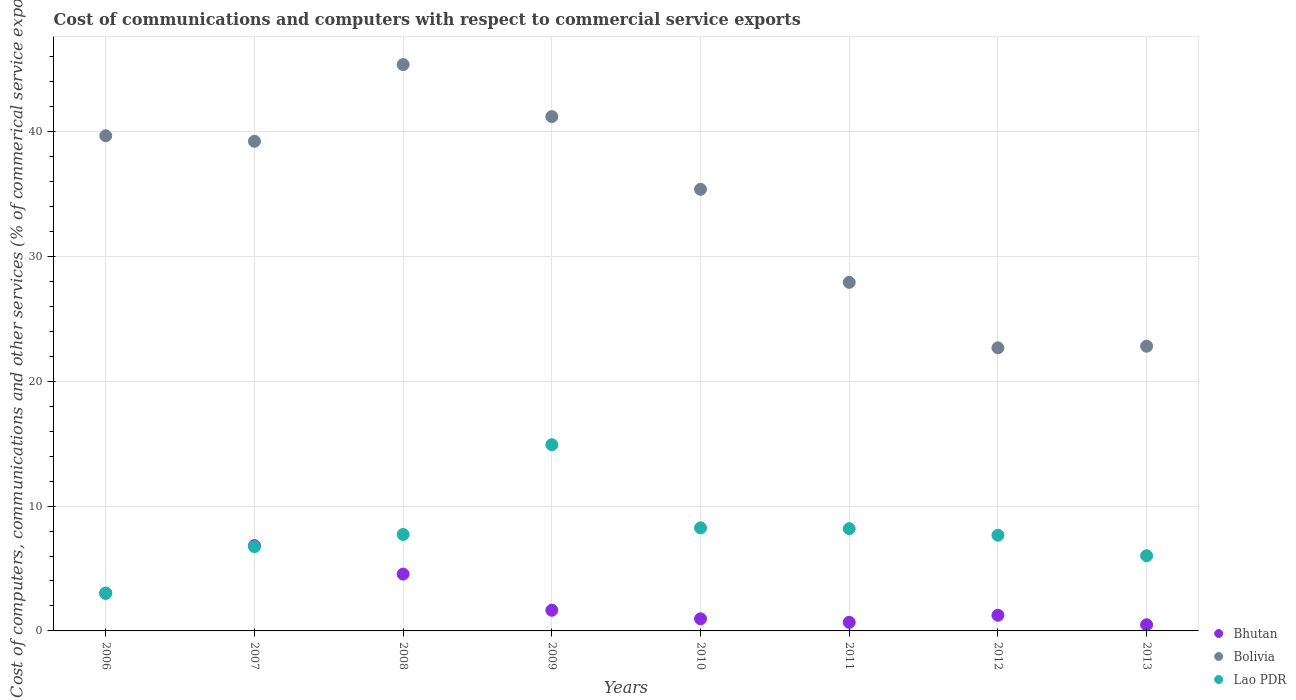How many different coloured dotlines are there?
Offer a terse response. 3. What is the cost of communications and computers in Bolivia in 2006?
Make the answer very short. 39.65. Across all years, what is the maximum cost of communications and computers in Bolivia?
Your answer should be very brief. 45.36. Across all years, what is the minimum cost of communications and computers in Lao PDR?
Offer a very short reply. 3.03. In which year was the cost of communications and computers in Lao PDR minimum?
Your answer should be compact. 2006. What is the total cost of communications and computers in Lao PDR in the graph?
Give a very brief answer. 62.54. What is the difference between the cost of communications and computers in Lao PDR in 2008 and that in 2009?
Provide a short and direct response. -7.19. What is the difference between the cost of communications and computers in Bhutan in 2010 and the cost of communications and computers in Lao PDR in 2012?
Offer a very short reply. -6.69. What is the average cost of communications and computers in Bhutan per year?
Provide a short and direct response. 2.43. In the year 2006, what is the difference between the cost of communications and computers in Lao PDR and cost of communications and computers in Bolivia?
Offer a terse response. -36.63. In how many years, is the cost of communications and computers in Lao PDR greater than 8 %?
Give a very brief answer. 3. What is the ratio of the cost of communications and computers in Bolivia in 2007 to that in 2013?
Ensure brevity in your answer.  1.72. What is the difference between the highest and the second highest cost of communications and computers in Bolivia?
Offer a very short reply. 4.16. What is the difference between the highest and the lowest cost of communications and computers in Lao PDR?
Keep it short and to the point. 11.88. Is the sum of the cost of communications and computers in Bolivia in 2006 and 2011 greater than the maximum cost of communications and computers in Lao PDR across all years?
Your answer should be very brief. Yes. Is it the case that in every year, the sum of the cost of communications and computers in Bhutan and cost of communications and computers in Lao PDR  is greater than the cost of communications and computers in Bolivia?
Provide a short and direct response. No. Does the cost of communications and computers in Lao PDR monotonically increase over the years?
Your response must be concise. No. Is the cost of communications and computers in Bhutan strictly greater than the cost of communications and computers in Bolivia over the years?
Ensure brevity in your answer.  No. Is the cost of communications and computers in Lao PDR strictly less than the cost of communications and computers in Bolivia over the years?
Provide a short and direct response. Yes. Are the values on the major ticks of Y-axis written in scientific E-notation?
Your answer should be compact. No. Where does the legend appear in the graph?
Your answer should be compact. Bottom right. What is the title of the graph?
Make the answer very short. Cost of communications and computers with respect to commercial service exports. What is the label or title of the Y-axis?
Make the answer very short. Cost of computers, communications and other services (% of commerical service exports). What is the Cost of computers, communications and other services (% of commerical service exports) in Bhutan in 2006?
Offer a very short reply. 3.02. What is the Cost of computers, communications and other services (% of commerical service exports) of Bolivia in 2006?
Provide a short and direct response. 39.65. What is the Cost of computers, communications and other services (% of commerical service exports) in Lao PDR in 2006?
Give a very brief answer. 3.03. What is the Cost of computers, communications and other services (% of commerical service exports) in Bhutan in 2007?
Give a very brief answer. 6.83. What is the Cost of computers, communications and other services (% of commerical service exports) in Bolivia in 2007?
Offer a terse response. 39.21. What is the Cost of computers, communications and other services (% of commerical service exports) of Lao PDR in 2007?
Your response must be concise. 6.74. What is the Cost of computers, communications and other services (% of commerical service exports) in Bhutan in 2008?
Your answer should be very brief. 4.55. What is the Cost of computers, communications and other services (% of commerical service exports) in Bolivia in 2008?
Keep it short and to the point. 45.36. What is the Cost of computers, communications and other services (% of commerical service exports) of Lao PDR in 2008?
Offer a very short reply. 7.72. What is the Cost of computers, communications and other services (% of commerical service exports) in Bhutan in 2009?
Offer a very short reply. 1.66. What is the Cost of computers, communications and other services (% of commerical service exports) of Bolivia in 2009?
Make the answer very short. 41.19. What is the Cost of computers, communications and other services (% of commerical service exports) in Lao PDR in 2009?
Give a very brief answer. 14.91. What is the Cost of computers, communications and other services (% of commerical service exports) of Bhutan in 2010?
Your response must be concise. 0.97. What is the Cost of computers, communications and other services (% of commerical service exports) in Bolivia in 2010?
Provide a succinct answer. 35.37. What is the Cost of computers, communications and other services (% of commerical service exports) of Lao PDR in 2010?
Offer a very short reply. 8.25. What is the Cost of computers, communications and other services (% of commerical service exports) in Bhutan in 2011?
Keep it short and to the point. 0.69. What is the Cost of computers, communications and other services (% of commerical service exports) of Bolivia in 2011?
Offer a terse response. 27.92. What is the Cost of computers, communications and other services (% of commerical service exports) in Lao PDR in 2011?
Make the answer very short. 8.19. What is the Cost of computers, communications and other services (% of commerical service exports) of Bhutan in 2012?
Give a very brief answer. 1.25. What is the Cost of computers, communications and other services (% of commerical service exports) in Bolivia in 2012?
Offer a very short reply. 22.67. What is the Cost of computers, communications and other services (% of commerical service exports) of Lao PDR in 2012?
Your answer should be compact. 7.66. What is the Cost of computers, communications and other services (% of commerical service exports) of Bhutan in 2013?
Keep it short and to the point. 0.49. What is the Cost of computers, communications and other services (% of commerical service exports) in Bolivia in 2013?
Give a very brief answer. 22.8. What is the Cost of computers, communications and other services (% of commerical service exports) in Lao PDR in 2013?
Ensure brevity in your answer.  6.02. Across all years, what is the maximum Cost of computers, communications and other services (% of commerical service exports) of Bhutan?
Your answer should be compact. 6.83. Across all years, what is the maximum Cost of computers, communications and other services (% of commerical service exports) in Bolivia?
Offer a very short reply. 45.36. Across all years, what is the maximum Cost of computers, communications and other services (% of commerical service exports) of Lao PDR?
Offer a terse response. 14.91. Across all years, what is the minimum Cost of computers, communications and other services (% of commerical service exports) in Bhutan?
Provide a short and direct response. 0.49. Across all years, what is the minimum Cost of computers, communications and other services (% of commerical service exports) of Bolivia?
Provide a succinct answer. 22.67. Across all years, what is the minimum Cost of computers, communications and other services (% of commerical service exports) of Lao PDR?
Offer a very short reply. 3.03. What is the total Cost of computers, communications and other services (% of commerical service exports) in Bhutan in the graph?
Your response must be concise. 19.46. What is the total Cost of computers, communications and other services (% of commerical service exports) in Bolivia in the graph?
Make the answer very short. 274.17. What is the total Cost of computers, communications and other services (% of commerical service exports) of Lao PDR in the graph?
Your answer should be compact. 62.54. What is the difference between the Cost of computers, communications and other services (% of commerical service exports) of Bhutan in 2006 and that in 2007?
Your answer should be compact. -3.81. What is the difference between the Cost of computers, communications and other services (% of commerical service exports) of Bolivia in 2006 and that in 2007?
Offer a terse response. 0.44. What is the difference between the Cost of computers, communications and other services (% of commerical service exports) in Lao PDR in 2006 and that in 2007?
Your answer should be very brief. -3.71. What is the difference between the Cost of computers, communications and other services (% of commerical service exports) in Bhutan in 2006 and that in 2008?
Offer a very short reply. -1.53. What is the difference between the Cost of computers, communications and other services (% of commerical service exports) in Bolivia in 2006 and that in 2008?
Offer a terse response. -5.7. What is the difference between the Cost of computers, communications and other services (% of commerical service exports) of Lao PDR in 2006 and that in 2008?
Your response must be concise. -4.69. What is the difference between the Cost of computers, communications and other services (% of commerical service exports) in Bhutan in 2006 and that in 2009?
Your answer should be compact. 1.36. What is the difference between the Cost of computers, communications and other services (% of commerical service exports) in Bolivia in 2006 and that in 2009?
Offer a terse response. -1.54. What is the difference between the Cost of computers, communications and other services (% of commerical service exports) in Lao PDR in 2006 and that in 2009?
Your answer should be very brief. -11.88. What is the difference between the Cost of computers, communications and other services (% of commerical service exports) in Bhutan in 2006 and that in 2010?
Make the answer very short. 2.05. What is the difference between the Cost of computers, communications and other services (% of commerical service exports) of Bolivia in 2006 and that in 2010?
Offer a terse response. 4.29. What is the difference between the Cost of computers, communications and other services (% of commerical service exports) of Lao PDR in 2006 and that in 2010?
Your answer should be compact. -5.22. What is the difference between the Cost of computers, communications and other services (% of commerical service exports) of Bhutan in 2006 and that in 2011?
Ensure brevity in your answer.  2.33. What is the difference between the Cost of computers, communications and other services (% of commerical service exports) in Bolivia in 2006 and that in 2011?
Provide a succinct answer. 11.74. What is the difference between the Cost of computers, communications and other services (% of commerical service exports) of Lao PDR in 2006 and that in 2011?
Your answer should be very brief. -5.16. What is the difference between the Cost of computers, communications and other services (% of commerical service exports) in Bhutan in 2006 and that in 2012?
Offer a terse response. 1.76. What is the difference between the Cost of computers, communications and other services (% of commerical service exports) in Bolivia in 2006 and that in 2012?
Make the answer very short. 16.99. What is the difference between the Cost of computers, communications and other services (% of commerical service exports) of Lao PDR in 2006 and that in 2012?
Provide a short and direct response. -4.63. What is the difference between the Cost of computers, communications and other services (% of commerical service exports) of Bhutan in 2006 and that in 2013?
Your answer should be compact. 2.52. What is the difference between the Cost of computers, communications and other services (% of commerical service exports) of Bolivia in 2006 and that in 2013?
Your answer should be compact. 16.85. What is the difference between the Cost of computers, communications and other services (% of commerical service exports) of Lao PDR in 2006 and that in 2013?
Your answer should be compact. -2.99. What is the difference between the Cost of computers, communications and other services (% of commerical service exports) in Bhutan in 2007 and that in 2008?
Give a very brief answer. 2.28. What is the difference between the Cost of computers, communications and other services (% of commerical service exports) of Bolivia in 2007 and that in 2008?
Provide a succinct answer. -6.14. What is the difference between the Cost of computers, communications and other services (% of commerical service exports) of Lao PDR in 2007 and that in 2008?
Keep it short and to the point. -0.98. What is the difference between the Cost of computers, communications and other services (% of commerical service exports) of Bhutan in 2007 and that in 2009?
Give a very brief answer. 5.18. What is the difference between the Cost of computers, communications and other services (% of commerical service exports) of Bolivia in 2007 and that in 2009?
Provide a short and direct response. -1.98. What is the difference between the Cost of computers, communications and other services (% of commerical service exports) of Lao PDR in 2007 and that in 2009?
Provide a succinct answer. -8.17. What is the difference between the Cost of computers, communications and other services (% of commerical service exports) of Bhutan in 2007 and that in 2010?
Offer a very short reply. 5.86. What is the difference between the Cost of computers, communications and other services (% of commerical service exports) of Bolivia in 2007 and that in 2010?
Keep it short and to the point. 3.85. What is the difference between the Cost of computers, communications and other services (% of commerical service exports) of Lao PDR in 2007 and that in 2010?
Your response must be concise. -1.51. What is the difference between the Cost of computers, communications and other services (% of commerical service exports) in Bhutan in 2007 and that in 2011?
Your answer should be compact. 6.14. What is the difference between the Cost of computers, communications and other services (% of commerical service exports) of Bolivia in 2007 and that in 2011?
Your response must be concise. 11.3. What is the difference between the Cost of computers, communications and other services (% of commerical service exports) in Lao PDR in 2007 and that in 2011?
Provide a short and direct response. -1.45. What is the difference between the Cost of computers, communications and other services (% of commerical service exports) of Bhutan in 2007 and that in 2012?
Provide a short and direct response. 5.58. What is the difference between the Cost of computers, communications and other services (% of commerical service exports) in Bolivia in 2007 and that in 2012?
Offer a very short reply. 16.54. What is the difference between the Cost of computers, communications and other services (% of commerical service exports) of Lao PDR in 2007 and that in 2012?
Offer a very short reply. -0.92. What is the difference between the Cost of computers, communications and other services (% of commerical service exports) in Bhutan in 2007 and that in 2013?
Your answer should be very brief. 6.34. What is the difference between the Cost of computers, communications and other services (% of commerical service exports) of Bolivia in 2007 and that in 2013?
Keep it short and to the point. 16.41. What is the difference between the Cost of computers, communications and other services (% of commerical service exports) in Lao PDR in 2007 and that in 2013?
Provide a short and direct response. 0.72. What is the difference between the Cost of computers, communications and other services (% of commerical service exports) of Bhutan in 2008 and that in 2009?
Provide a short and direct response. 2.89. What is the difference between the Cost of computers, communications and other services (% of commerical service exports) of Bolivia in 2008 and that in 2009?
Provide a succinct answer. 4.16. What is the difference between the Cost of computers, communications and other services (% of commerical service exports) of Lao PDR in 2008 and that in 2009?
Your answer should be compact. -7.19. What is the difference between the Cost of computers, communications and other services (% of commerical service exports) of Bhutan in 2008 and that in 2010?
Your answer should be very brief. 3.58. What is the difference between the Cost of computers, communications and other services (% of commerical service exports) in Bolivia in 2008 and that in 2010?
Ensure brevity in your answer.  9.99. What is the difference between the Cost of computers, communications and other services (% of commerical service exports) of Lao PDR in 2008 and that in 2010?
Offer a terse response. -0.53. What is the difference between the Cost of computers, communications and other services (% of commerical service exports) of Bhutan in 2008 and that in 2011?
Keep it short and to the point. 3.86. What is the difference between the Cost of computers, communications and other services (% of commerical service exports) of Bolivia in 2008 and that in 2011?
Offer a very short reply. 17.44. What is the difference between the Cost of computers, communications and other services (% of commerical service exports) of Lao PDR in 2008 and that in 2011?
Ensure brevity in your answer.  -0.46. What is the difference between the Cost of computers, communications and other services (% of commerical service exports) of Bhutan in 2008 and that in 2012?
Provide a succinct answer. 3.3. What is the difference between the Cost of computers, communications and other services (% of commerical service exports) of Bolivia in 2008 and that in 2012?
Your response must be concise. 22.69. What is the difference between the Cost of computers, communications and other services (% of commerical service exports) of Lao PDR in 2008 and that in 2012?
Keep it short and to the point. 0.06. What is the difference between the Cost of computers, communications and other services (% of commerical service exports) in Bhutan in 2008 and that in 2013?
Your answer should be very brief. 4.06. What is the difference between the Cost of computers, communications and other services (% of commerical service exports) of Bolivia in 2008 and that in 2013?
Offer a very short reply. 22.55. What is the difference between the Cost of computers, communications and other services (% of commerical service exports) of Lao PDR in 2008 and that in 2013?
Ensure brevity in your answer.  1.7. What is the difference between the Cost of computers, communications and other services (% of commerical service exports) in Bhutan in 2009 and that in 2010?
Your answer should be very brief. 0.69. What is the difference between the Cost of computers, communications and other services (% of commerical service exports) of Bolivia in 2009 and that in 2010?
Make the answer very short. 5.82. What is the difference between the Cost of computers, communications and other services (% of commerical service exports) of Lao PDR in 2009 and that in 2010?
Make the answer very short. 6.66. What is the difference between the Cost of computers, communications and other services (% of commerical service exports) in Bhutan in 2009 and that in 2011?
Provide a short and direct response. 0.97. What is the difference between the Cost of computers, communications and other services (% of commerical service exports) in Bolivia in 2009 and that in 2011?
Your response must be concise. 13.28. What is the difference between the Cost of computers, communications and other services (% of commerical service exports) in Lao PDR in 2009 and that in 2011?
Offer a very short reply. 6.72. What is the difference between the Cost of computers, communications and other services (% of commerical service exports) in Bhutan in 2009 and that in 2012?
Ensure brevity in your answer.  0.4. What is the difference between the Cost of computers, communications and other services (% of commerical service exports) of Bolivia in 2009 and that in 2012?
Your answer should be very brief. 18.52. What is the difference between the Cost of computers, communications and other services (% of commerical service exports) in Lao PDR in 2009 and that in 2012?
Your answer should be very brief. 7.25. What is the difference between the Cost of computers, communications and other services (% of commerical service exports) in Bhutan in 2009 and that in 2013?
Your response must be concise. 1.16. What is the difference between the Cost of computers, communications and other services (% of commerical service exports) of Bolivia in 2009 and that in 2013?
Keep it short and to the point. 18.39. What is the difference between the Cost of computers, communications and other services (% of commerical service exports) in Lao PDR in 2009 and that in 2013?
Make the answer very short. 8.89. What is the difference between the Cost of computers, communications and other services (% of commerical service exports) of Bhutan in 2010 and that in 2011?
Your answer should be compact. 0.28. What is the difference between the Cost of computers, communications and other services (% of commerical service exports) of Bolivia in 2010 and that in 2011?
Your answer should be very brief. 7.45. What is the difference between the Cost of computers, communications and other services (% of commerical service exports) of Lao PDR in 2010 and that in 2011?
Give a very brief answer. 0.06. What is the difference between the Cost of computers, communications and other services (% of commerical service exports) of Bhutan in 2010 and that in 2012?
Provide a succinct answer. -0.28. What is the difference between the Cost of computers, communications and other services (% of commerical service exports) of Bolivia in 2010 and that in 2012?
Provide a short and direct response. 12.7. What is the difference between the Cost of computers, communications and other services (% of commerical service exports) in Lao PDR in 2010 and that in 2012?
Your answer should be very brief. 0.59. What is the difference between the Cost of computers, communications and other services (% of commerical service exports) of Bhutan in 2010 and that in 2013?
Offer a terse response. 0.47. What is the difference between the Cost of computers, communications and other services (% of commerical service exports) of Bolivia in 2010 and that in 2013?
Offer a terse response. 12.57. What is the difference between the Cost of computers, communications and other services (% of commerical service exports) in Lao PDR in 2010 and that in 2013?
Give a very brief answer. 2.23. What is the difference between the Cost of computers, communications and other services (% of commerical service exports) in Bhutan in 2011 and that in 2012?
Ensure brevity in your answer.  -0.56. What is the difference between the Cost of computers, communications and other services (% of commerical service exports) in Bolivia in 2011 and that in 2012?
Offer a terse response. 5.25. What is the difference between the Cost of computers, communications and other services (% of commerical service exports) of Lao PDR in 2011 and that in 2012?
Your response must be concise. 0.53. What is the difference between the Cost of computers, communications and other services (% of commerical service exports) of Bhutan in 2011 and that in 2013?
Your answer should be compact. 0.2. What is the difference between the Cost of computers, communications and other services (% of commerical service exports) of Bolivia in 2011 and that in 2013?
Offer a very short reply. 5.11. What is the difference between the Cost of computers, communications and other services (% of commerical service exports) of Lao PDR in 2011 and that in 2013?
Offer a very short reply. 2.17. What is the difference between the Cost of computers, communications and other services (% of commerical service exports) of Bhutan in 2012 and that in 2013?
Give a very brief answer. 0.76. What is the difference between the Cost of computers, communications and other services (% of commerical service exports) in Bolivia in 2012 and that in 2013?
Offer a very short reply. -0.13. What is the difference between the Cost of computers, communications and other services (% of commerical service exports) in Lao PDR in 2012 and that in 2013?
Make the answer very short. 1.64. What is the difference between the Cost of computers, communications and other services (% of commerical service exports) of Bhutan in 2006 and the Cost of computers, communications and other services (% of commerical service exports) of Bolivia in 2007?
Offer a very short reply. -36.2. What is the difference between the Cost of computers, communications and other services (% of commerical service exports) of Bhutan in 2006 and the Cost of computers, communications and other services (% of commerical service exports) of Lao PDR in 2007?
Your answer should be compact. -3.73. What is the difference between the Cost of computers, communications and other services (% of commerical service exports) of Bolivia in 2006 and the Cost of computers, communications and other services (% of commerical service exports) of Lao PDR in 2007?
Give a very brief answer. 32.91. What is the difference between the Cost of computers, communications and other services (% of commerical service exports) in Bhutan in 2006 and the Cost of computers, communications and other services (% of commerical service exports) in Bolivia in 2008?
Give a very brief answer. -42.34. What is the difference between the Cost of computers, communications and other services (% of commerical service exports) of Bhutan in 2006 and the Cost of computers, communications and other services (% of commerical service exports) of Lao PDR in 2008?
Make the answer very short. -4.71. What is the difference between the Cost of computers, communications and other services (% of commerical service exports) of Bolivia in 2006 and the Cost of computers, communications and other services (% of commerical service exports) of Lao PDR in 2008?
Your response must be concise. 31.93. What is the difference between the Cost of computers, communications and other services (% of commerical service exports) in Bhutan in 2006 and the Cost of computers, communications and other services (% of commerical service exports) in Bolivia in 2009?
Give a very brief answer. -38.17. What is the difference between the Cost of computers, communications and other services (% of commerical service exports) of Bhutan in 2006 and the Cost of computers, communications and other services (% of commerical service exports) of Lao PDR in 2009?
Offer a terse response. -11.9. What is the difference between the Cost of computers, communications and other services (% of commerical service exports) of Bolivia in 2006 and the Cost of computers, communications and other services (% of commerical service exports) of Lao PDR in 2009?
Make the answer very short. 24.74. What is the difference between the Cost of computers, communications and other services (% of commerical service exports) in Bhutan in 2006 and the Cost of computers, communications and other services (% of commerical service exports) in Bolivia in 2010?
Offer a terse response. -32.35. What is the difference between the Cost of computers, communications and other services (% of commerical service exports) of Bhutan in 2006 and the Cost of computers, communications and other services (% of commerical service exports) of Lao PDR in 2010?
Offer a very short reply. -5.24. What is the difference between the Cost of computers, communications and other services (% of commerical service exports) in Bolivia in 2006 and the Cost of computers, communications and other services (% of commerical service exports) in Lao PDR in 2010?
Provide a succinct answer. 31.4. What is the difference between the Cost of computers, communications and other services (% of commerical service exports) of Bhutan in 2006 and the Cost of computers, communications and other services (% of commerical service exports) of Bolivia in 2011?
Your answer should be compact. -24.9. What is the difference between the Cost of computers, communications and other services (% of commerical service exports) in Bhutan in 2006 and the Cost of computers, communications and other services (% of commerical service exports) in Lao PDR in 2011?
Make the answer very short. -5.17. What is the difference between the Cost of computers, communications and other services (% of commerical service exports) of Bolivia in 2006 and the Cost of computers, communications and other services (% of commerical service exports) of Lao PDR in 2011?
Offer a terse response. 31.47. What is the difference between the Cost of computers, communications and other services (% of commerical service exports) in Bhutan in 2006 and the Cost of computers, communications and other services (% of commerical service exports) in Bolivia in 2012?
Keep it short and to the point. -19.65. What is the difference between the Cost of computers, communications and other services (% of commerical service exports) in Bhutan in 2006 and the Cost of computers, communications and other services (% of commerical service exports) in Lao PDR in 2012?
Provide a short and direct response. -4.65. What is the difference between the Cost of computers, communications and other services (% of commerical service exports) of Bolivia in 2006 and the Cost of computers, communications and other services (% of commerical service exports) of Lao PDR in 2012?
Your answer should be very brief. 31.99. What is the difference between the Cost of computers, communications and other services (% of commerical service exports) in Bhutan in 2006 and the Cost of computers, communications and other services (% of commerical service exports) in Bolivia in 2013?
Keep it short and to the point. -19.78. What is the difference between the Cost of computers, communications and other services (% of commerical service exports) of Bhutan in 2006 and the Cost of computers, communications and other services (% of commerical service exports) of Lao PDR in 2013?
Offer a terse response. -3.01. What is the difference between the Cost of computers, communications and other services (% of commerical service exports) in Bolivia in 2006 and the Cost of computers, communications and other services (% of commerical service exports) in Lao PDR in 2013?
Ensure brevity in your answer.  33.63. What is the difference between the Cost of computers, communications and other services (% of commerical service exports) of Bhutan in 2007 and the Cost of computers, communications and other services (% of commerical service exports) of Bolivia in 2008?
Your answer should be compact. -38.52. What is the difference between the Cost of computers, communications and other services (% of commerical service exports) in Bhutan in 2007 and the Cost of computers, communications and other services (% of commerical service exports) in Lao PDR in 2008?
Offer a terse response. -0.89. What is the difference between the Cost of computers, communications and other services (% of commerical service exports) in Bolivia in 2007 and the Cost of computers, communications and other services (% of commerical service exports) in Lao PDR in 2008?
Keep it short and to the point. 31.49. What is the difference between the Cost of computers, communications and other services (% of commerical service exports) of Bhutan in 2007 and the Cost of computers, communications and other services (% of commerical service exports) of Bolivia in 2009?
Offer a terse response. -34.36. What is the difference between the Cost of computers, communications and other services (% of commerical service exports) of Bhutan in 2007 and the Cost of computers, communications and other services (% of commerical service exports) of Lao PDR in 2009?
Your answer should be very brief. -8.08. What is the difference between the Cost of computers, communications and other services (% of commerical service exports) in Bolivia in 2007 and the Cost of computers, communications and other services (% of commerical service exports) in Lao PDR in 2009?
Provide a short and direct response. 24.3. What is the difference between the Cost of computers, communications and other services (% of commerical service exports) in Bhutan in 2007 and the Cost of computers, communications and other services (% of commerical service exports) in Bolivia in 2010?
Your answer should be very brief. -28.53. What is the difference between the Cost of computers, communications and other services (% of commerical service exports) of Bhutan in 2007 and the Cost of computers, communications and other services (% of commerical service exports) of Lao PDR in 2010?
Provide a short and direct response. -1.42. What is the difference between the Cost of computers, communications and other services (% of commerical service exports) of Bolivia in 2007 and the Cost of computers, communications and other services (% of commerical service exports) of Lao PDR in 2010?
Your answer should be compact. 30.96. What is the difference between the Cost of computers, communications and other services (% of commerical service exports) of Bhutan in 2007 and the Cost of computers, communications and other services (% of commerical service exports) of Bolivia in 2011?
Keep it short and to the point. -21.08. What is the difference between the Cost of computers, communications and other services (% of commerical service exports) of Bhutan in 2007 and the Cost of computers, communications and other services (% of commerical service exports) of Lao PDR in 2011?
Offer a terse response. -1.36. What is the difference between the Cost of computers, communications and other services (% of commerical service exports) of Bolivia in 2007 and the Cost of computers, communications and other services (% of commerical service exports) of Lao PDR in 2011?
Make the answer very short. 31.02. What is the difference between the Cost of computers, communications and other services (% of commerical service exports) of Bhutan in 2007 and the Cost of computers, communications and other services (% of commerical service exports) of Bolivia in 2012?
Provide a succinct answer. -15.84. What is the difference between the Cost of computers, communications and other services (% of commerical service exports) of Bhutan in 2007 and the Cost of computers, communications and other services (% of commerical service exports) of Lao PDR in 2012?
Give a very brief answer. -0.83. What is the difference between the Cost of computers, communications and other services (% of commerical service exports) of Bolivia in 2007 and the Cost of computers, communications and other services (% of commerical service exports) of Lao PDR in 2012?
Your answer should be very brief. 31.55. What is the difference between the Cost of computers, communications and other services (% of commerical service exports) in Bhutan in 2007 and the Cost of computers, communications and other services (% of commerical service exports) in Bolivia in 2013?
Offer a terse response. -15.97. What is the difference between the Cost of computers, communications and other services (% of commerical service exports) of Bhutan in 2007 and the Cost of computers, communications and other services (% of commerical service exports) of Lao PDR in 2013?
Your answer should be very brief. 0.81. What is the difference between the Cost of computers, communications and other services (% of commerical service exports) of Bolivia in 2007 and the Cost of computers, communications and other services (% of commerical service exports) of Lao PDR in 2013?
Give a very brief answer. 33.19. What is the difference between the Cost of computers, communications and other services (% of commerical service exports) in Bhutan in 2008 and the Cost of computers, communications and other services (% of commerical service exports) in Bolivia in 2009?
Provide a succinct answer. -36.64. What is the difference between the Cost of computers, communications and other services (% of commerical service exports) in Bhutan in 2008 and the Cost of computers, communications and other services (% of commerical service exports) in Lao PDR in 2009?
Give a very brief answer. -10.36. What is the difference between the Cost of computers, communications and other services (% of commerical service exports) in Bolivia in 2008 and the Cost of computers, communications and other services (% of commerical service exports) in Lao PDR in 2009?
Offer a terse response. 30.44. What is the difference between the Cost of computers, communications and other services (% of commerical service exports) in Bhutan in 2008 and the Cost of computers, communications and other services (% of commerical service exports) in Bolivia in 2010?
Your answer should be compact. -30.82. What is the difference between the Cost of computers, communications and other services (% of commerical service exports) in Bhutan in 2008 and the Cost of computers, communications and other services (% of commerical service exports) in Lao PDR in 2010?
Ensure brevity in your answer.  -3.7. What is the difference between the Cost of computers, communications and other services (% of commerical service exports) of Bolivia in 2008 and the Cost of computers, communications and other services (% of commerical service exports) of Lao PDR in 2010?
Provide a short and direct response. 37.1. What is the difference between the Cost of computers, communications and other services (% of commerical service exports) of Bhutan in 2008 and the Cost of computers, communications and other services (% of commerical service exports) of Bolivia in 2011?
Offer a very short reply. -23.36. What is the difference between the Cost of computers, communications and other services (% of commerical service exports) in Bhutan in 2008 and the Cost of computers, communications and other services (% of commerical service exports) in Lao PDR in 2011?
Make the answer very short. -3.64. What is the difference between the Cost of computers, communications and other services (% of commerical service exports) of Bolivia in 2008 and the Cost of computers, communications and other services (% of commerical service exports) of Lao PDR in 2011?
Give a very brief answer. 37.17. What is the difference between the Cost of computers, communications and other services (% of commerical service exports) in Bhutan in 2008 and the Cost of computers, communications and other services (% of commerical service exports) in Bolivia in 2012?
Your answer should be very brief. -18.12. What is the difference between the Cost of computers, communications and other services (% of commerical service exports) in Bhutan in 2008 and the Cost of computers, communications and other services (% of commerical service exports) in Lao PDR in 2012?
Provide a short and direct response. -3.11. What is the difference between the Cost of computers, communications and other services (% of commerical service exports) in Bolivia in 2008 and the Cost of computers, communications and other services (% of commerical service exports) in Lao PDR in 2012?
Provide a short and direct response. 37.69. What is the difference between the Cost of computers, communications and other services (% of commerical service exports) of Bhutan in 2008 and the Cost of computers, communications and other services (% of commerical service exports) of Bolivia in 2013?
Make the answer very short. -18.25. What is the difference between the Cost of computers, communications and other services (% of commerical service exports) of Bhutan in 2008 and the Cost of computers, communications and other services (% of commerical service exports) of Lao PDR in 2013?
Give a very brief answer. -1.47. What is the difference between the Cost of computers, communications and other services (% of commerical service exports) in Bolivia in 2008 and the Cost of computers, communications and other services (% of commerical service exports) in Lao PDR in 2013?
Ensure brevity in your answer.  39.33. What is the difference between the Cost of computers, communications and other services (% of commerical service exports) in Bhutan in 2009 and the Cost of computers, communications and other services (% of commerical service exports) in Bolivia in 2010?
Provide a short and direct response. -33.71. What is the difference between the Cost of computers, communications and other services (% of commerical service exports) of Bhutan in 2009 and the Cost of computers, communications and other services (% of commerical service exports) of Lao PDR in 2010?
Provide a succinct answer. -6.6. What is the difference between the Cost of computers, communications and other services (% of commerical service exports) in Bolivia in 2009 and the Cost of computers, communications and other services (% of commerical service exports) in Lao PDR in 2010?
Provide a succinct answer. 32.94. What is the difference between the Cost of computers, communications and other services (% of commerical service exports) in Bhutan in 2009 and the Cost of computers, communications and other services (% of commerical service exports) in Bolivia in 2011?
Offer a very short reply. -26.26. What is the difference between the Cost of computers, communications and other services (% of commerical service exports) of Bhutan in 2009 and the Cost of computers, communications and other services (% of commerical service exports) of Lao PDR in 2011?
Provide a short and direct response. -6.53. What is the difference between the Cost of computers, communications and other services (% of commerical service exports) of Bolivia in 2009 and the Cost of computers, communications and other services (% of commerical service exports) of Lao PDR in 2011?
Provide a short and direct response. 33. What is the difference between the Cost of computers, communications and other services (% of commerical service exports) of Bhutan in 2009 and the Cost of computers, communications and other services (% of commerical service exports) of Bolivia in 2012?
Your answer should be very brief. -21.01. What is the difference between the Cost of computers, communications and other services (% of commerical service exports) of Bhutan in 2009 and the Cost of computers, communications and other services (% of commerical service exports) of Lao PDR in 2012?
Your answer should be compact. -6.01. What is the difference between the Cost of computers, communications and other services (% of commerical service exports) in Bolivia in 2009 and the Cost of computers, communications and other services (% of commerical service exports) in Lao PDR in 2012?
Provide a short and direct response. 33.53. What is the difference between the Cost of computers, communications and other services (% of commerical service exports) of Bhutan in 2009 and the Cost of computers, communications and other services (% of commerical service exports) of Bolivia in 2013?
Your answer should be very brief. -21.14. What is the difference between the Cost of computers, communications and other services (% of commerical service exports) in Bhutan in 2009 and the Cost of computers, communications and other services (% of commerical service exports) in Lao PDR in 2013?
Your answer should be very brief. -4.37. What is the difference between the Cost of computers, communications and other services (% of commerical service exports) of Bolivia in 2009 and the Cost of computers, communications and other services (% of commerical service exports) of Lao PDR in 2013?
Offer a very short reply. 35.17. What is the difference between the Cost of computers, communications and other services (% of commerical service exports) in Bhutan in 2010 and the Cost of computers, communications and other services (% of commerical service exports) in Bolivia in 2011?
Your answer should be compact. -26.95. What is the difference between the Cost of computers, communications and other services (% of commerical service exports) of Bhutan in 2010 and the Cost of computers, communications and other services (% of commerical service exports) of Lao PDR in 2011?
Keep it short and to the point. -7.22. What is the difference between the Cost of computers, communications and other services (% of commerical service exports) of Bolivia in 2010 and the Cost of computers, communications and other services (% of commerical service exports) of Lao PDR in 2011?
Offer a terse response. 27.18. What is the difference between the Cost of computers, communications and other services (% of commerical service exports) of Bhutan in 2010 and the Cost of computers, communications and other services (% of commerical service exports) of Bolivia in 2012?
Offer a terse response. -21.7. What is the difference between the Cost of computers, communications and other services (% of commerical service exports) in Bhutan in 2010 and the Cost of computers, communications and other services (% of commerical service exports) in Lao PDR in 2012?
Make the answer very short. -6.69. What is the difference between the Cost of computers, communications and other services (% of commerical service exports) of Bolivia in 2010 and the Cost of computers, communications and other services (% of commerical service exports) of Lao PDR in 2012?
Your answer should be very brief. 27.7. What is the difference between the Cost of computers, communications and other services (% of commerical service exports) of Bhutan in 2010 and the Cost of computers, communications and other services (% of commerical service exports) of Bolivia in 2013?
Offer a very short reply. -21.83. What is the difference between the Cost of computers, communications and other services (% of commerical service exports) of Bhutan in 2010 and the Cost of computers, communications and other services (% of commerical service exports) of Lao PDR in 2013?
Make the answer very short. -5.05. What is the difference between the Cost of computers, communications and other services (% of commerical service exports) of Bolivia in 2010 and the Cost of computers, communications and other services (% of commerical service exports) of Lao PDR in 2013?
Make the answer very short. 29.34. What is the difference between the Cost of computers, communications and other services (% of commerical service exports) in Bhutan in 2011 and the Cost of computers, communications and other services (% of commerical service exports) in Bolivia in 2012?
Offer a terse response. -21.98. What is the difference between the Cost of computers, communications and other services (% of commerical service exports) in Bhutan in 2011 and the Cost of computers, communications and other services (% of commerical service exports) in Lao PDR in 2012?
Offer a terse response. -6.97. What is the difference between the Cost of computers, communications and other services (% of commerical service exports) in Bolivia in 2011 and the Cost of computers, communications and other services (% of commerical service exports) in Lao PDR in 2012?
Your answer should be very brief. 20.25. What is the difference between the Cost of computers, communications and other services (% of commerical service exports) of Bhutan in 2011 and the Cost of computers, communications and other services (% of commerical service exports) of Bolivia in 2013?
Give a very brief answer. -22.11. What is the difference between the Cost of computers, communications and other services (% of commerical service exports) of Bhutan in 2011 and the Cost of computers, communications and other services (% of commerical service exports) of Lao PDR in 2013?
Your answer should be very brief. -5.33. What is the difference between the Cost of computers, communications and other services (% of commerical service exports) of Bolivia in 2011 and the Cost of computers, communications and other services (% of commerical service exports) of Lao PDR in 2013?
Make the answer very short. 21.89. What is the difference between the Cost of computers, communications and other services (% of commerical service exports) in Bhutan in 2012 and the Cost of computers, communications and other services (% of commerical service exports) in Bolivia in 2013?
Provide a succinct answer. -21.55. What is the difference between the Cost of computers, communications and other services (% of commerical service exports) in Bhutan in 2012 and the Cost of computers, communications and other services (% of commerical service exports) in Lao PDR in 2013?
Offer a terse response. -4.77. What is the difference between the Cost of computers, communications and other services (% of commerical service exports) in Bolivia in 2012 and the Cost of computers, communications and other services (% of commerical service exports) in Lao PDR in 2013?
Make the answer very short. 16.65. What is the average Cost of computers, communications and other services (% of commerical service exports) of Bhutan per year?
Your answer should be very brief. 2.43. What is the average Cost of computers, communications and other services (% of commerical service exports) in Bolivia per year?
Your response must be concise. 34.27. What is the average Cost of computers, communications and other services (% of commerical service exports) of Lao PDR per year?
Your answer should be compact. 7.82. In the year 2006, what is the difference between the Cost of computers, communications and other services (% of commerical service exports) of Bhutan and Cost of computers, communications and other services (% of commerical service exports) of Bolivia?
Keep it short and to the point. -36.64. In the year 2006, what is the difference between the Cost of computers, communications and other services (% of commerical service exports) in Bhutan and Cost of computers, communications and other services (% of commerical service exports) in Lao PDR?
Keep it short and to the point. -0.01. In the year 2006, what is the difference between the Cost of computers, communications and other services (% of commerical service exports) of Bolivia and Cost of computers, communications and other services (% of commerical service exports) of Lao PDR?
Your answer should be compact. 36.63. In the year 2007, what is the difference between the Cost of computers, communications and other services (% of commerical service exports) of Bhutan and Cost of computers, communications and other services (% of commerical service exports) of Bolivia?
Provide a short and direct response. -32.38. In the year 2007, what is the difference between the Cost of computers, communications and other services (% of commerical service exports) of Bhutan and Cost of computers, communications and other services (% of commerical service exports) of Lao PDR?
Make the answer very short. 0.09. In the year 2007, what is the difference between the Cost of computers, communications and other services (% of commerical service exports) of Bolivia and Cost of computers, communications and other services (% of commerical service exports) of Lao PDR?
Provide a short and direct response. 32.47. In the year 2008, what is the difference between the Cost of computers, communications and other services (% of commerical service exports) in Bhutan and Cost of computers, communications and other services (% of commerical service exports) in Bolivia?
Your response must be concise. -40.8. In the year 2008, what is the difference between the Cost of computers, communications and other services (% of commerical service exports) of Bhutan and Cost of computers, communications and other services (% of commerical service exports) of Lao PDR?
Your answer should be compact. -3.17. In the year 2008, what is the difference between the Cost of computers, communications and other services (% of commerical service exports) of Bolivia and Cost of computers, communications and other services (% of commerical service exports) of Lao PDR?
Offer a very short reply. 37.63. In the year 2009, what is the difference between the Cost of computers, communications and other services (% of commerical service exports) of Bhutan and Cost of computers, communications and other services (% of commerical service exports) of Bolivia?
Keep it short and to the point. -39.53. In the year 2009, what is the difference between the Cost of computers, communications and other services (% of commerical service exports) of Bhutan and Cost of computers, communications and other services (% of commerical service exports) of Lao PDR?
Make the answer very short. -13.26. In the year 2009, what is the difference between the Cost of computers, communications and other services (% of commerical service exports) of Bolivia and Cost of computers, communications and other services (% of commerical service exports) of Lao PDR?
Make the answer very short. 26.28. In the year 2010, what is the difference between the Cost of computers, communications and other services (% of commerical service exports) in Bhutan and Cost of computers, communications and other services (% of commerical service exports) in Bolivia?
Your answer should be compact. -34.4. In the year 2010, what is the difference between the Cost of computers, communications and other services (% of commerical service exports) in Bhutan and Cost of computers, communications and other services (% of commerical service exports) in Lao PDR?
Your answer should be compact. -7.28. In the year 2010, what is the difference between the Cost of computers, communications and other services (% of commerical service exports) in Bolivia and Cost of computers, communications and other services (% of commerical service exports) in Lao PDR?
Provide a succinct answer. 27.11. In the year 2011, what is the difference between the Cost of computers, communications and other services (% of commerical service exports) in Bhutan and Cost of computers, communications and other services (% of commerical service exports) in Bolivia?
Your answer should be very brief. -27.22. In the year 2011, what is the difference between the Cost of computers, communications and other services (% of commerical service exports) in Bhutan and Cost of computers, communications and other services (% of commerical service exports) in Lao PDR?
Your answer should be very brief. -7.5. In the year 2011, what is the difference between the Cost of computers, communications and other services (% of commerical service exports) of Bolivia and Cost of computers, communications and other services (% of commerical service exports) of Lao PDR?
Offer a terse response. 19.73. In the year 2012, what is the difference between the Cost of computers, communications and other services (% of commerical service exports) of Bhutan and Cost of computers, communications and other services (% of commerical service exports) of Bolivia?
Provide a succinct answer. -21.42. In the year 2012, what is the difference between the Cost of computers, communications and other services (% of commerical service exports) in Bhutan and Cost of computers, communications and other services (% of commerical service exports) in Lao PDR?
Provide a succinct answer. -6.41. In the year 2012, what is the difference between the Cost of computers, communications and other services (% of commerical service exports) of Bolivia and Cost of computers, communications and other services (% of commerical service exports) of Lao PDR?
Offer a very short reply. 15.01. In the year 2013, what is the difference between the Cost of computers, communications and other services (% of commerical service exports) in Bhutan and Cost of computers, communications and other services (% of commerical service exports) in Bolivia?
Give a very brief answer. -22.31. In the year 2013, what is the difference between the Cost of computers, communications and other services (% of commerical service exports) in Bhutan and Cost of computers, communications and other services (% of commerical service exports) in Lao PDR?
Your answer should be very brief. -5.53. In the year 2013, what is the difference between the Cost of computers, communications and other services (% of commerical service exports) of Bolivia and Cost of computers, communications and other services (% of commerical service exports) of Lao PDR?
Your answer should be compact. 16.78. What is the ratio of the Cost of computers, communications and other services (% of commerical service exports) in Bhutan in 2006 to that in 2007?
Give a very brief answer. 0.44. What is the ratio of the Cost of computers, communications and other services (% of commerical service exports) of Bolivia in 2006 to that in 2007?
Your response must be concise. 1.01. What is the ratio of the Cost of computers, communications and other services (% of commerical service exports) in Lao PDR in 2006 to that in 2007?
Ensure brevity in your answer.  0.45. What is the ratio of the Cost of computers, communications and other services (% of commerical service exports) in Bhutan in 2006 to that in 2008?
Give a very brief answer. 0.66. What is the ratio of the Cost of computers, communications and other services (% of commerical service exports) of Bolivia in 2006 to that in 2008?
Keep it short and to the point. 0.87. What is the ratio of the Cost of computers, communications and other services (% of commerical service exports) in Lao PDR in 2006 to that in 2008?
Give a very brief answer. 0.39. What is the ratio of the Cost of computers, communications and other services (% of commerical service exports) in Bhutan in 2006 to that in 2009?
Your answer should be very brief. 1.82. What is the ratio of the Cost of computers, communications and other services (% of commerical service exports) of Bolivia in 2006 to that in 2009?
Your answer should be very brief. 0.96. What is the ratio of the Cost of computers, communications and other services (% of commerical service exports) of Lao PDR in 2006 to that in 2009?
Ensure brevity in your answer.  0.2. What is the ratio of the Cost of computers, communications and other services (% of commerical service exports) in Bhutan in 2006 to that in 2010?
Provide a short and direct response. 3.11. What is the ratio of the Cost of computers, communications and other services (% of commerical service exports) in Bolivia in 2006 to that in 2010?
Keep it short and to the point. 1.12. What is the ratio of the Cost of computers, communications and other services (% of commerical service exports) in Lao PDR in 2006 to that in 2010?
Your response must be concise. 0.37. What is the ratio of the Cost of computers, communications and other services (% of commerical service exports) in Bhutan in 2006 to that in 2011?
Offer a very short reply. 4.37. What is the ratio of the Cost of computers, communications and other services (% of commerical service exports) in Bolivia in 2006 to that in 2011?
Give a very brief answer. 1.42. What is the ratio of the Cost of computers, communications and other services (% of commerical service exports) of Lao PDR in 2006 to that in 2011?
Provide a succinct answer. 0.37. What is the ratio of the Cost of computers, communications and other services (% of commerical service exports) in Bhutan in 2006 to that in 2012?
Offer a terse response. 2.41. What is the ratio of the Cost of computers, communications and other services (% of commerical service exports) in Bolivia in 2006 to that in 2012?
Offer a very short reply. 1.75. What is the ratio of the Cost of computers, communications and other services (% of commerical service exports) of Lao PDR in 2006 to that in 2012?
Your answer should be compact. 0.4. What is the ratio of the Cost of computers, communications and other services (% of commerical service exports) in Bhutan in 2006 to that in 2013?
Offer a very short reply. 6.1. What is the ratio of the Cost of computers, communications and other services (% of commerical service exports) in Bolivia in 2006 to that in 2013?
Your answer should be compact. 1.74. What is the ratio of the Cost of computers, communications and other services (% of commerical service exports) of Lao PDR in 2006 to that in 2013?
Ensure brevity in your answer.  0.5. What is the ratio of the Cost of computers, communications and other services (% of commerical service exports) in Bhutan in 2007 to that in 2008?
Ensure brevity in your answer.  1.5. What is the ratio of the Cost of computers, communications and other services (% of commerical service exports) of Bolivia in 2007 to that in 2008?
Give a very brief answer. 0.86. What is the ratio of the Cost of computers, communications and other services (% of commerical service exports) in Lao PDR in 2007 to that in 2008?
Your answer should be very brief. 0.87. What is the ratio of the Cost of computers, communications and other services (% of commerical service exports) of Bhutan in 2007 to that in 2009?
Provide a short and direct response. 4.12. What is the ratio of the Cost of computers, communications and other services (% of commerical service exports) in Bolivia in 2007 to that in 2009?
Offer a terse response. 0.95. What is the ratio of the Cost of computers, communications and other services (% of commerical service exports) of Lao PDR in 2007 to that in 2009?
Make the answer very short. 0.45. What is the ratio of the Cost of computers, communications and other services (% of commerical service exports) of Bhutan in 2007 to that in 2010?
Make the answer very short. 7.05. What is the ratio of the Cost of computers, communications and other services (% of commerical service exports) of Bolivia in 2007 to that in 2010?
Offer a very short reply. 1.11. What is the ratio of the Cost of computers, communications and other services (% of commerical service exports) in Lao PDR in 2007 to that in 2010?
Give a very brief answer. 0.82. What is the ratio of the Cost of computers, communications and other services (% of commerical service exports) of Bhutan in 2007 to that in 2011?
Ensure brevity in your answer.  9.89. What is the ratio of the Cost of computers, communications and other services (% of commerical service exports) of Bolivia in 2007 to that in 2011?
Your response must be concise. 1.4. What is the ratio of the Cost of computers, communications and other services (% of commerical service exports) of Lao PDR in 2007 to that in 2011?
Your response must be concise. 0.82. What is the ratio of the Cost of computers, communications and other services (% of commerical service exports) in Bhutan in 2007 to that in 2012?
Offer a terse response. 5.45. What is the ratio of the Cost of computers, communications and other services (% of commerical service exports) of Bolivia in 2007 to that in 2012?
Your answer should be compact. 1.73. What is the ratio of the Cost of computers, communications and other services (% of commerical service exports) of Lao PDR in 2007 to that in 2012?
Your answer should be very brief. 0.88. What is the ratio of the Cost of computers, communications and other services (% of commerical service exports) in Bhutan in 2007 to that in 2013?
Make the answer very short. 13.81. What is the ratio of the Cost of computers, communications and other services (% of commerical service exports) of Bolivia in 2007 to that in 2013?
Provide a short and direct response. 1.72. What is the ratio of the Cost of computers, communications and other services (% of commerical service exports) of Lao PDR in 2007 to that in 2013?
Your answer should be compact. 1.12. What is the ratio of the Cost of computers, communications and other services (% of commerical service exports) in Bhutan in 2008 to that in 2009?
Ensure brevity in your answer.  2.75. What is the ratio of the Cost of computers, communications and other services (% of commerical service exports) in Bolivia in 2008 to that in 2009?
Ensure brevity in your answer.  1.1. What is the ratio of the Cost of computers, communications and other services (% of commerical service exports) in Lao PDR in 2008 to that in 2009?
Your answer should be compact. 0.52. What is the ratio of the Cost of computers, communications and other services (% of commerical service exports) in Bhutan in 2008 to that in 2010?
Give a very brief answer. 4.7. What is the ratio of the Cost of computers, communications and other services (% of commerical service exports) in Bolivia in 2008 to that in 2010?
Provide a succinct answer. 1.28. What is the ratio of the Cost of computers, communications and other services (% of commerical service exports) of Lao PDR in 2008 to that in 2010?
Your answer should be very brief. 0.94. What is the ratio of the Cost of computers, communications and other services (% of commerical service exports) of Bhutan in 2008 to that in 2011?
Offer a terse response. 6.59. What is the ratio of the Cost of computers, communications and other services (% of commerical service exports) of Bolivia in 2008 to that in 2011?
Make the answer very short. 1.62. What is the ratio of the Cost of computers, communications and other services (% of commerical service exports) of Lao PDR in 2008 to that in 2011?
Ensure brevity in your answer.  0.94. What is the ratio of the Cost of computers, communications and other services (% of commerical service exports) of Bhutan in 2008 to that in 2012?
Ensure brevity in your answer.  3.63. What is the ratio of the Cost of computers, communications and other services (% of commerical service exports) of Bolivia in 2008 to that in 2012?
Make the answer very short. 2. What is the ratio of the Cost of computers, communications and other services (% of commerical service exports) of Bhutan in 2008 to that in 2013?
Your answer should be compact. 9.2. What is the ratio of the Cost of computers, communications and other services (% of commerical service exports) of Bolivia in 2008 to that in 2013?
Ensure brevity in your answer.  1.99. What is the ratio of the Cost of computers, communications and other services (% of commerical service exports) in Lao PDR in 2008 to that in 2013?
Offer a terse response. 1.28. What is the ratio of the Cost of computers, communications and other services (% of commerical service exports) of Bhutan in 2009 to that in 2010?
Make the answer very short. 1.71. What is the ratio of the Cost of computers, communications and other services (% of commerical service exports) in Bolivia in 2009 to that in 2010?
Provide a short and direct response. 1.16. What is the ratio of the Cost of computers, communications and other services (% of commerical service exports) in Lao PDR in 2009 to that in 2010?
Offer a very short reply. 1.81. What is the ratio of the Cost of computers, communications and other services (% of commerical service exports) in Bhutan in 2009 to that in 2011?
Your answer should be very brief. 2.4. What is the ratio of the Cost of computers, communications and other services (% of commerical service exports) in Bolivia in 2009 to that in 2011?
Your answer should be compact. 1.48. What is the ratio of the Cost of computers, communications and other services (% of commerical service exports) of Lao PDR in 2009 to that in 2011?
Ensure brevity in your answer.  1.82. What is the ratio of the Cost of computers, communications and other services (% of commerical service exports) in Bhutan in 2009 to that in 2012?
Give a very brief answer. 1.32. What is the ratio of the Cost of computers, communications and other services (% of commerical service exports) in Bolivia in 2009 to that in 2012?
Make the answer very short. 1.82. What is the ratio of the Cost of computers, communications and other services (% of commerical service exports) in Lao PDR in 2009 to that in 2012?
Offer a terse response. 1.95. What is the ratio of the Cost of computers, communications and other services (% of commerical service exports) of Bhutan in 2009 to that in 2013?
Provide a succinct answer. 3.35. What is the ratio of the Cost of computers, communications and other services (% of commerical service exports) in Bolivia in 2009 to that in 2013?
Provide a short and direct response. 1.81. What is the ratio of the Cost of computers, communications and other services (% of commerical service exports) in Lao PDR in 2009 to that in 2013?
Give a very brief answer. 2.48. What is the ratio of the Cost of computers, communications and other services (% of commerical service exports) of Bhutan in 2010 to that in 2011?
Keep it short and to the point. 1.4. What is the ratio of the Cost of computers, communications and other services (% of commerical service exports) of Bolivia in 2010 to that in 2011?
Offer a very short reply. 1.27. What is the ratio of the Cost of computers, communications and other services (% of commerical service exports) in Lao PDR in 2010 to that in 2011?
Give a very brief answer. 1.01. What is the ratio of the Cost of computers, communications and other services (% of commerical service exports) of Bhutan in 2010 to that in 2012?
Keep it short and to the point. 0.77. What is the ratio of the Cost of computers, communications and other services (% of commerical service exports) in Bolivia in 2010 to that in 2012?
Your answer should be compact. 1.56. What is the ratio of the Cost of computers, communications and other services (% of commerical service exports) in Lao PDR in 2010 to that in 2012?
Give a very brief answer. 1.08. What is the ratio of the Cost of computers, communications and other services (% of commerical service exports) in Bhutan in 2010 to that in 2013?
Provide a short and direct response. 1.96. What is the ratio of the Cost of computers, communications and other services (% of commerical service exports) in Bolivia in 2010 to that in 2013?
Ensure brevity in your answer.  1.55. What is the ratio of the Cost of computers, communications and other services (% of commerical service exports) of Lao PDR in 2010 to that in 2013?
Offer a terse response. 1.37. What is the ratio of the Cost of computers, communications and other services (% of commerical service exports) of Bhutan in 2011 to that in 2012?
Keep it short and to the point. 0.55. What is the ratio of the Cost of computers, communications and other services (% of commerical service exports) in Bolivia in 2011 to that in 2012?
Provide a short and direct response. 1.23. What is the ratio of the Cost of computers, communications and other services (% of commerical service exports) in Lao PDR in 2011 to that in 2012?
Make the answer very short. 1.07. What is the ratio of the Cost of computers, communications and other services (% of commerical service exports) in Bhutan in 2011 to that in 2013?
Keep it short and to the point. 1.4. What is the ratio of the Cost of computers, communications and other services (% of commerical service exports) of Bolivia in 2011 to that in 2013?
Provide a succinct answer. 1.22. What is the ratio of the Cost of computers, communications and other services (% of commerical service exports) in Lao PDR in 2011 to that in 2013?
Make the answer very short. 1.36. What is the ratio of the Cost of computers, communications and other services (% of commerical service exports) of Bhutan in 2012 to that in 2013?
Give a very brief answer. 2.53. What is the ratio of the Cost of computers, communications and other services (% of commerical service exports) in Bolivia in 2012 to that in 2013?
Your answer should be very brief. 0.99. What is the ratio of the Cost of computers, communications and other services (% of commerical service exports) in Lao PDR in 2012 to that in 2013?
Give a very brief answer. 1.27. What is the difference between the highest and the second highest Cost of computers, communications and other services (% of commerical service exports) in Bhutan?
Make the answer very short. 2.28. What is the difference between the highest and the second highest Cost of computers, communications and other services (% of commerical service exports) of Bolivia?
Your response must be concise. 4.16. What is the difference between the highest and the second highest Cost of computers, communications and other services (% of commerical service exports) in Lao PDR?
Your response must be concise. 6.66. What is the difference between the highest and the lowest Cost of computers, communications and other services (% of commerical service exports) of Bhutan?
Make the answer very short. 6.34. What is the difference between the highest and the lowest Cost of computers, communications and other services (% of commerical service exports) in Bolivia?
Your answer should be very brief. 22.69. What is the difference between the highest and the lowest Cost of computers, communications and other services (% of commerical service exports) in Lao PDR?
Offer a very short reply. 11.88. 